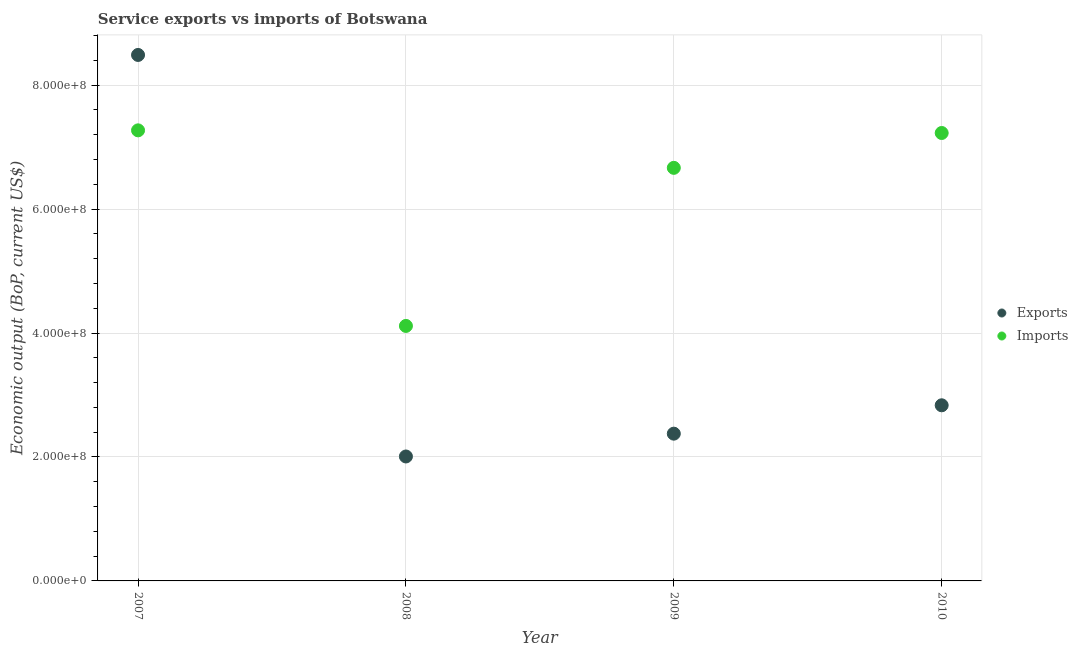How many different coloured dotlines are there?
Provide a succinct answer. 2. What is the amount of service exports in 2007?
Offer a terse response. 8.49e+08. Across all years, what is the maximum amount of service exports?
Offer a terse response. 8.49e+08. Across all years, what is the minimum amount of service imports?
Offer a terse response. 4.12e+08. In which year was the amount of service exports minimum?
Your answer should be very brief. 2008. What is the total amount of service exports in the graph?
Provide a succinct answer. 1.57e+09. What is the difference between the amount of service exports in 2007 and that in 2010?
Your answer should be compact. 5.65e+08. What is the difference between the amount of service exports in 2009 and the amount of service imports in 2008?
Offer a very short reply. -1.74e+08. What is the average amount of service exports per year?
Your answer should be compact. 3.93e+08. In the year 2009, what is the difference between the amount of service imports and amount of service exports?
Make the answer very short. 4.29e+08. In how many years, is the amount of service imports greater than 760000000 US$?
Your answer should be very brief. 0. What is the ratio of the amount of service imports in 2007 to that in 2009?
Your response must be concise. 1.09. Is the amount of service imports in 2008 less than that in 2010?
Give a very brief answer. Yes. Is the difference between the amount of service exports in 2007 and 2008 greater than the difference between the amount of service imports in 2007 and 2008?
Your answer should be compact. Yes. What is the difference between the highest and the second highest amount of service imports?
Keep it short and to the point. 4.27e+06. What is the difference between the highest and the lowest amount of service imports?
Your response must be concise. 3.16e+08. Does the amount of service exports monotonically increase over the years?
Provide a succinct answer. No. Is the amount of service exports strictly less than the amount of service imports over the years?
Your answer should be very brief. No. How many dotlines are there?
Offer a very short reply. 2. Are the values on the major ticks of Y-axis written in scientific E-notation?
Offer a terse response. Yes. Does the graph contain any zero values?
Provide a succinct answer. No. Does the graph contain grids?
Offer a terse response. Yes. Where does the legend appear in the graph?
Give a very brief answer. Center right. What is the title of the graph?
Provide a succinct answer. Service exports vs imports of Botswana. Does "Time to import" appear as one of the legend labels in the graph?
Provide a short and direct response. No. What is the label or title of the X-axis?
Your answer should be very brief. Year. What is the label or title of the Y-axis?
Provide a succinct answer. Economic output (BoP, current US$). What is the Economic output (BoP, current US$) in Exports in 2007?
Ensure brevity in your answer.  8.49e+08. What is the Economic output (BoP, current US$) in Imports in 2007?
Provide a short and direct response. 7.27e+08. What is the Economic output (BoP, current US$) of Exports in 2008?
Keep it short and to the point. 2.01e+08. What is the Economic output (BoP, current US$) of Imports in 2008?
Your response must be concise. 4.12e+08. What is the Economic output (BoP, current US$) of Exports in 2009?
Provide a succinct answer. 2.38e+08. What is the Economic output (BoP, current US$) in Imports in 2009?
Make the answer very short. 6.67e+08. What is the Economic output (BoP, current US$) in Exports in 2010?
Your answer should be very brief. 2.83e+08. What is the Economic output (BoP, current US$) in Imports in 2010?
Make the answer very short. 7.23e+08. Across all years, what is the maximum Economic output (BoP, current US$) of Exports?
Provide a short and direct response. 8.49e+08. Across all years, what is the maximum Economic output (BoP, current US$) in Imports?
Your response must be concise. 7.27e+08. Across all years, what is the minimum Economic output (BoP, current US$) of Exports?
Make the answer very short. 2.01e+08. Across all years, what is the minimum Economic output (BoP, current US$) of Imports?
Your answer should be very brief. 4.12e+08. What is the total Economic output (BoP, current US$) of Exports in the graph?
Offer a terse response. 1.57e+09. What is the total Economic output (BoP, current US$) in Imports in the graph?
Ensure brevity in your answer.  2.53e+09. What is the difference between the Economic output (BoP, current US$) of Exports in 2007 and that in 2008?
Make the answer very short. 6.48e+08. What is the difference between the Economic output (BoP, current US$) of Imports in 2007 and that in 2008?
Your answer should be very brief. 3.16e+08. What is the difference between the Economic output (BoP, current US$) in Exports in 2007 and that in 2009?
Keep it short and to the point. 6.11e+08. What is the difference between the Economic output (BoP, current US$) of Imports in 2007 and that in 2009?
Provide a succinct answer. 6.05e+07. What is the difference between the Economic output (BoP, current US$) of Exports in 2007 and that in 2010?
Offer a terse response. 5.65e+08. What is the difference between the Economic output (BoP, current US$) in Imports in 2007 and that in 2010?
Give a very brief answer. 4.27e+06. What is the difference between the Economic output (BoP, current US$) in Exports in 2008 and that in 2009?
Provide a succinct answer. -3.68e+07. What is the difference between the Economic output (BoP, current US$) in Imports in 2008 and that in 2009?
Offer a very short reply. -2.55e+08. What is the difference between the Economic output (BoP, current US$) of Exports in 2008 and that in 2010?
Offer a very short reply. -8.26e+07. What is the difference between the Economic output (BoP, current US$) in Imports in 2008 and that in 2010?
Your response must be concise. -3.11e+08. What is the difference between the Economic output (BoP, current US$) of Exports in 2009 and that in 2010?
Provide a succinct answer. -4.58e+07. What is the difference between the Economic output (BoP, current US$) of Imports in 2009 and that in 2010?
Keep it short and to the point. -5.62e+07. What is the difference between the Economic output (BoP, current US$) in Exports in 2007 and the Economic output (BoP, current US$) in Imports in 2008?
Offer a terse response. 4.37e+08. What is the difference between the Economic output (BoP, current US$) in Exports in 2007 and the Economic output (BoP, current US$) in Imports in 2009?
Your answer should be compact. 1.82e+08. What is the difference between the Economic output (BoP, current US$) in Exports in 2007 and the Economic output (BoP, current US$) in Imports in 2010?
Your response must be concise. 1.26e+08. What is the difference between the Economic output (BoP, current US$) in Exports in 2008 and the Economic output (BoP, current US$) in Imports in 2009?
Offer a very short reply. -4.66e+08. What is the difference between the Economic output (BoP, current US$) in Exports in 2008 and the Economic output (BoP, current US$) in Imports in 2010?
Provide a succinct answer. -5.22e+08. What is the difference between the Economic output (BoP, current US$) in Exports in 2009 and the Economic output (BoP, current US$) in Imports in 2010?
Offer a terse response. -4.85e+08. What is the average Economic output (BoP, current US$) of Exports per year?
Your answer should be compact. 3.93e+08. What is the average Economic output (BoP, current US$) in Imports per year?
Your answer should be very brief. 6.32e+08. In the year 2007, what is the difference between the Economic output (BoP, current US$) in Exports and Economic output (BoP, current US$) in Imports?
Offer a very short reply. 1.22e+08. In the year 2008, what is the difference between the Economic output (BoP, current US$) in Exports and Economic output (BoP, current US$) in Imports?
Offer a terse response. -2.11e+08. In the year 2009, what is the difference between the Economic output (BoP, current US$) in Exports and Economic output (BoP, current US$) in Imports?
Provide a short and direct response. -4.29e+08. In the year 2010, what is the difference between the Economic output (BoP, current US$) of Exports and Economic output (BoP, current US$) of Imports?
Make the answer very short. -4.39e+08. What is the ratio of the Economic output (BoP, current US$) in Exports in 2007 to that in 2008?
Ensure brevity in your answer.  4.23. What is the ratio of the Economic output (BoP, current US$) of Imports in 2007 to that in 2008?
Offer a very short reply. 1.77. What is the ratio of the Economic output (BoP, current US$) of Exports in 2007 to that in 2009?
Make the answer very short. 3.57. What is the ratio of the Economic output (BoP, current US$) of Imports in 2007 to that in 2009?
Your answer should be very brief. 1.09. What is the ratio of the Economic output (BoP, current US$) of Exports in 2007 to that in 2010?
Give a very brief answer. 2.99. What is the ratio of the Economic output (BoP, current US$) of Imports in 2007 to that in 2010?
Provide a short and direct response. 1.01. What is the ratio of the Economic output (BoP, current US$) of Exports in 2008 to that in 2009?
Your answer should be very brief. 0.85. What is the ratio of the Economic output (BoP, current US$) of Imports in 2008 to that in 2009?
Provide a short and direct response. 0.62. What is the ratio of the Economic output (BoP, current US$) in Exports in 2008 to that in 2010?
Offer a very short reply. 0.71. What is the ratio of the Economic output (BoP, current US$) of Imports in 2008 to that in 2010?
Your answer should be very brief. 0.57. What is the ratio of the Economic output (BoP, current US$) of Exports in 2009 to that in 2010?
Offer a terse response. 0.84. What is the ratio of the Economic output (BoP, current US$) in Imports in 2009 to that in 2010?
Provide a short and direct response. 0.92. What is the difference between the highest and the second highest Economic output (BoP, current US$) of Exports?
Offer a terse response. 5.65e+08. What is the difference between the highest and the second highest Economic output (BoP, current US$) in Imports?
Make the answer very short. 4.27e+06. What is the difference between the highest and the lowest Economic output (BoP, current US$) of Exports?
Offer a very short reply. 6.48e+08. What is the difference between the highest and the lowest Economic output (BoP, current US$) in Imports?
Your response must be concise. 3.16e+08. 